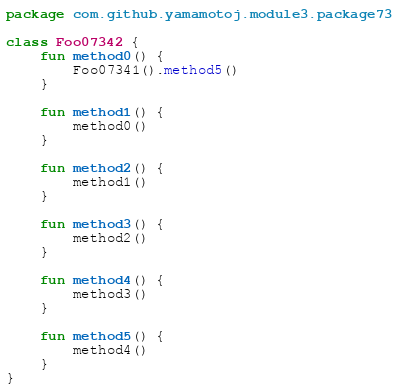Convert code to text. <code><loc_0><loc_0><loc_500><loc_500><_Kotlin_>package com.github.yamamotoj.module3.package73

class Foo07342 {
    fun method0() {
        Foo07341().method5()
    }

    fun method1() {
        method0()
    }

    fun method2() {
        method1()
    }

    fun method3() {
        method2()
    }

    fun method4() {
        method3()
    }

    fun method5() {
        method4()
    }
}
</code> 